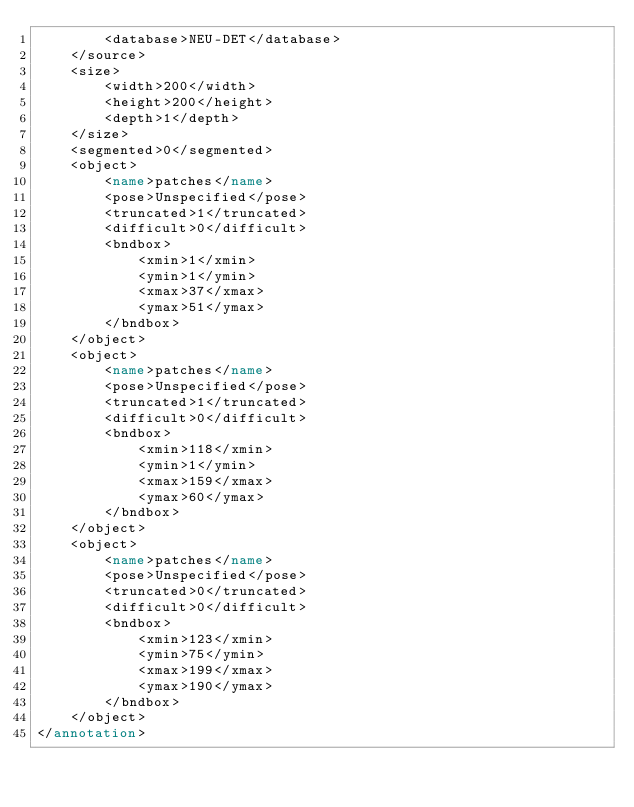<code> <loc_0><loc_0><loc_500><loc_500><_XML_>		<database>NEU-DET</database>
	</source>
	<size>
		<width>200</width>
		<height>200</height>
		<depth>1</depth>
	</size>
	<segmented>0</segmented>
	<object>
		<name>patches</name>
		<pose>Unspecified</pose>
		<truncated>1</truncated>
		<difficult>0</difficult>
		<bndbox>
			<xmin>1</xmin>
			<ymin>1</ymin>
			<xmax>37</xmax>
			<ymax>51</ymax>
		</bndbox>
	</object>
	<object>
		<name>patches</name>
		<pose>Unspecified</pose>
		<truncated>1</truncated>
		<difficult>0</difficult>
		<bndbox>
			<xmin>118</xmin>
			<ymin>1</ymin>
			<xmax>159</xmax>
			<ymax>60</ymax>
		</bndbox>
	</object>
	<object>
		<name>patches</name>
		<pose>Unspecified</pose>
		<truncated>0</truncated>
		<difficult>0</difficult>
		<bndbox>
			<xmin>123</xmin>
			<ymin>75</ymin>
			<xmax>199</xmax>
			<ymax>190</ymax>
		</bndbox>
	</object>
</annotation>
</code> 